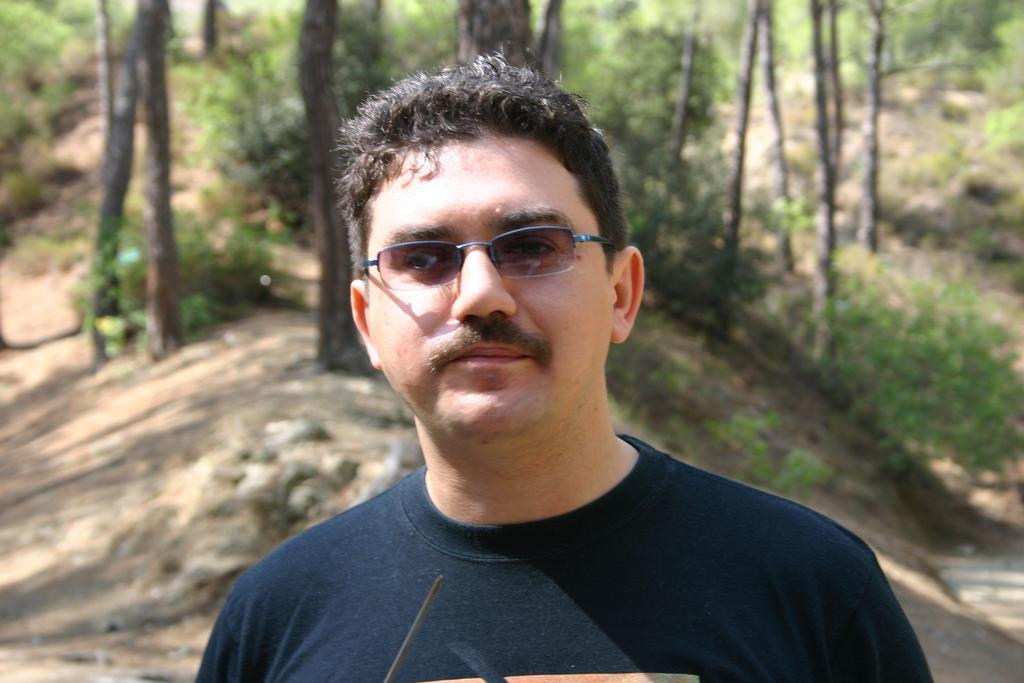What is the main subject of the image? There is a person standing in the middle of the image. What is the person doing in the image? The person is watching something. What can be seen in the background of the image? There are trees behind the person. Can you see any gold objects in the image? There is no mention of any gold objects in the image, so we cannot determine if any are present. 